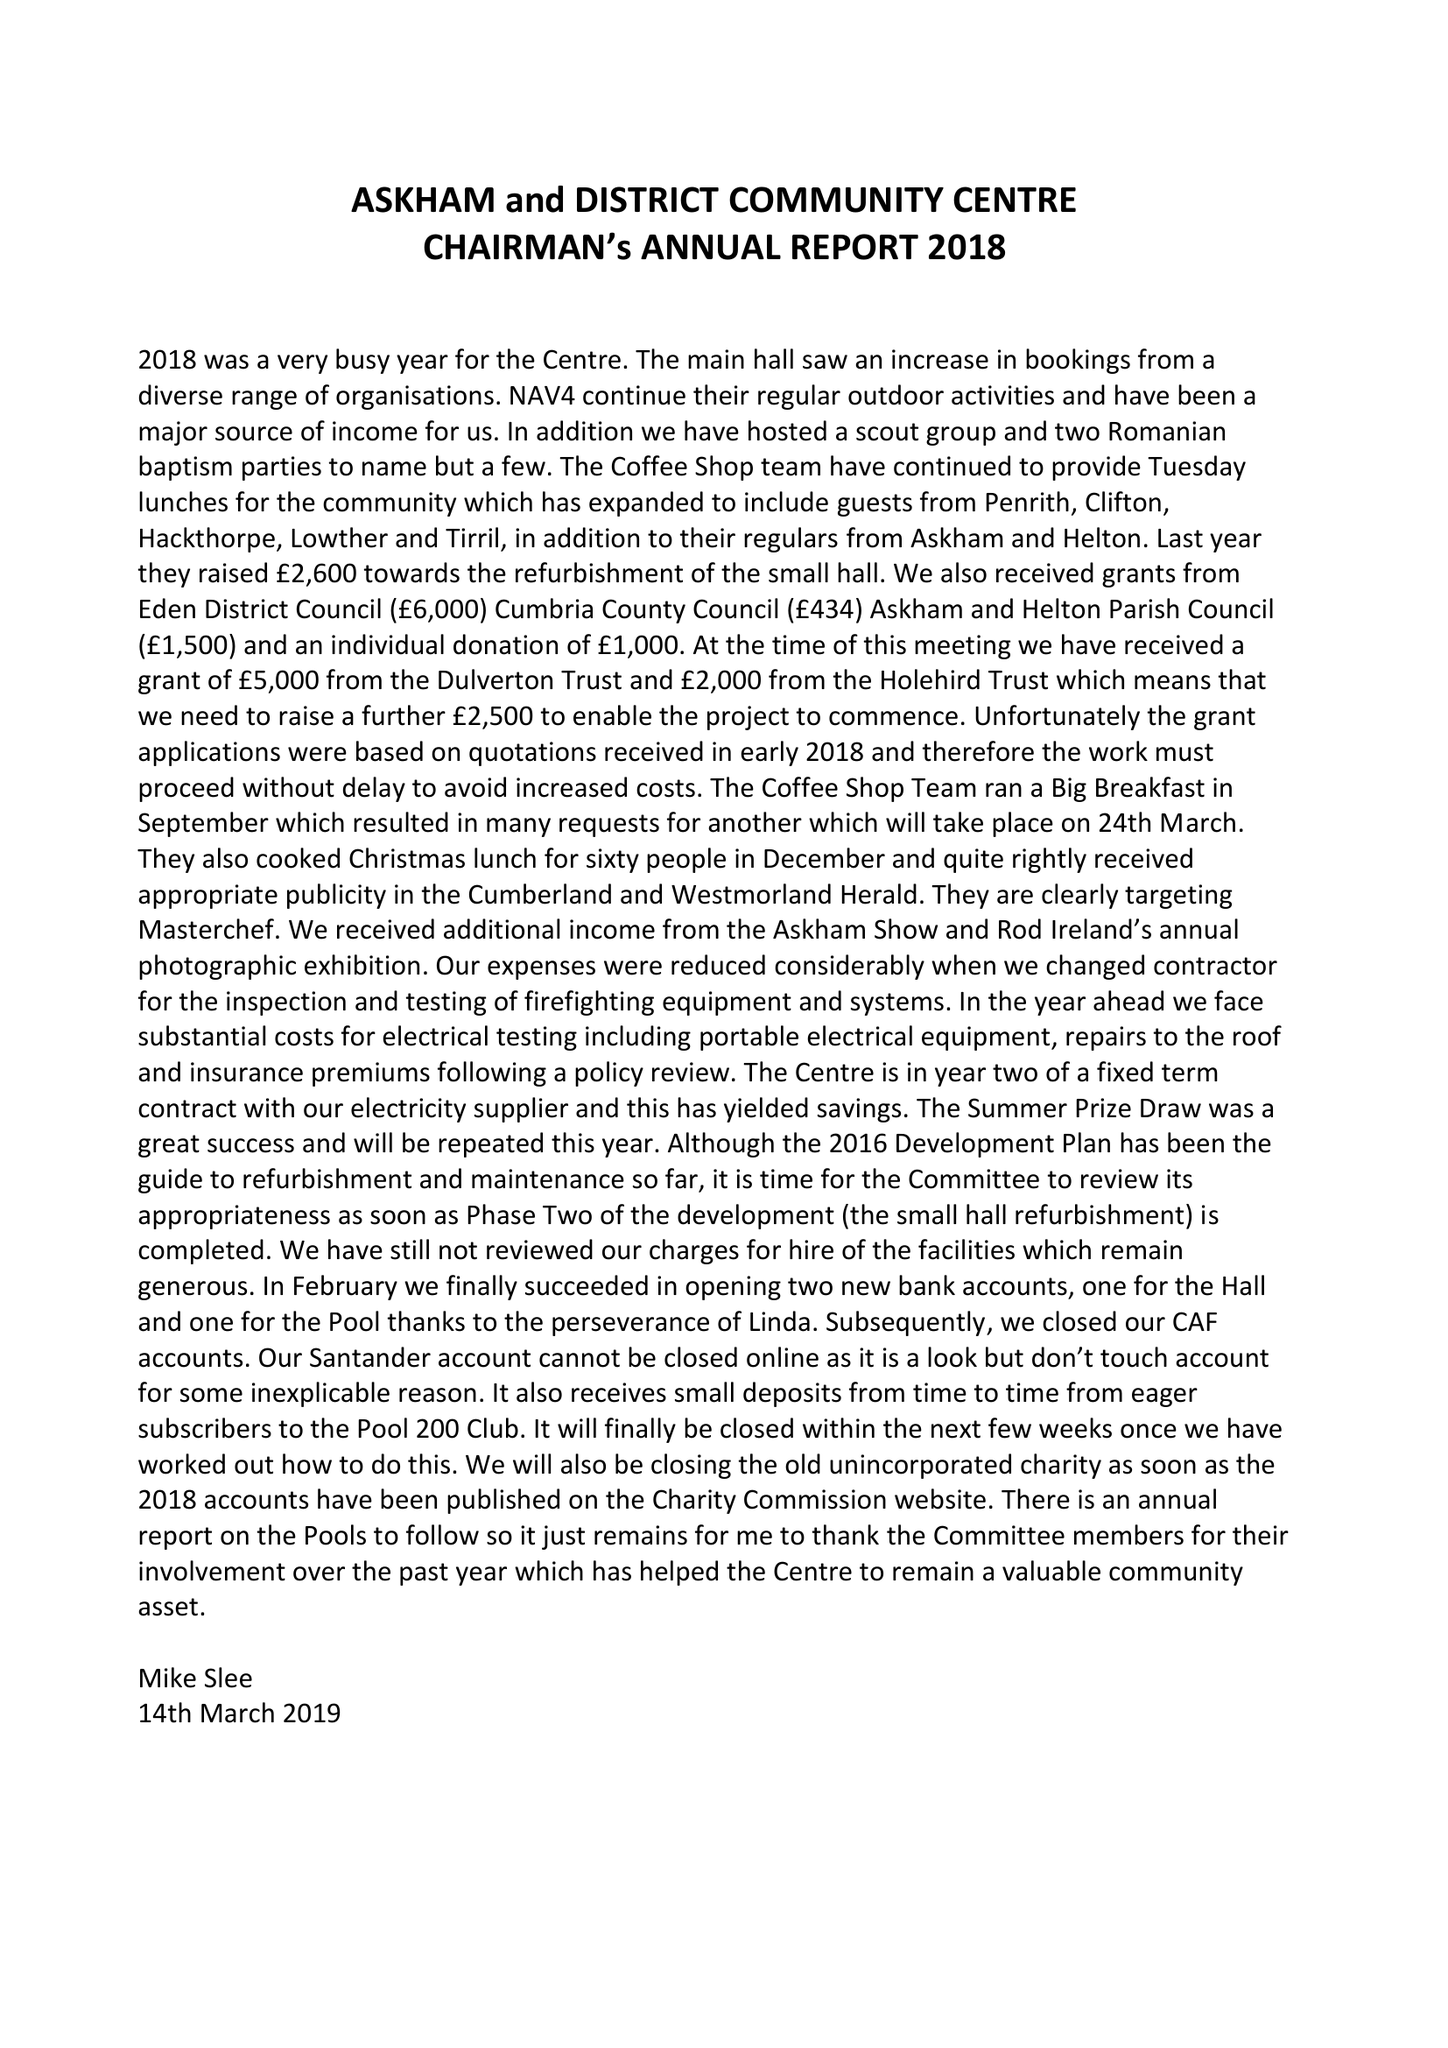What is the value for the charity_number?
Answer the question using a single word or phrase. 523049 